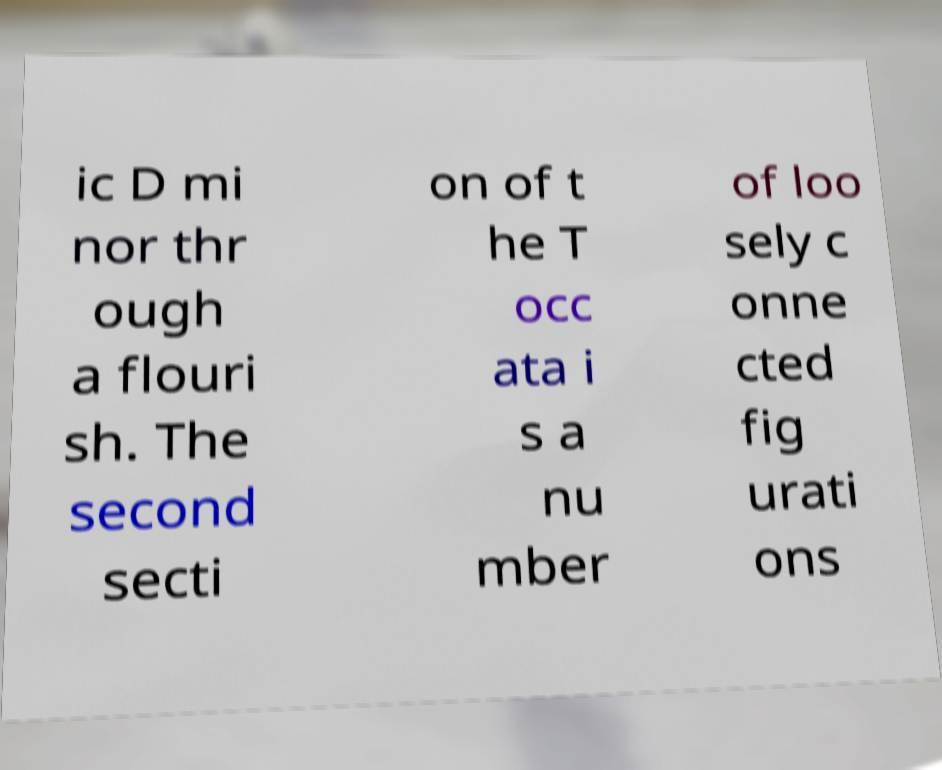Could you extract and type out the text from this image? ic D mi nor thr ough a flouri sh. The second secti on of t he T occ ata i s a nu mber of loo sely c onne cted fig urati ons 